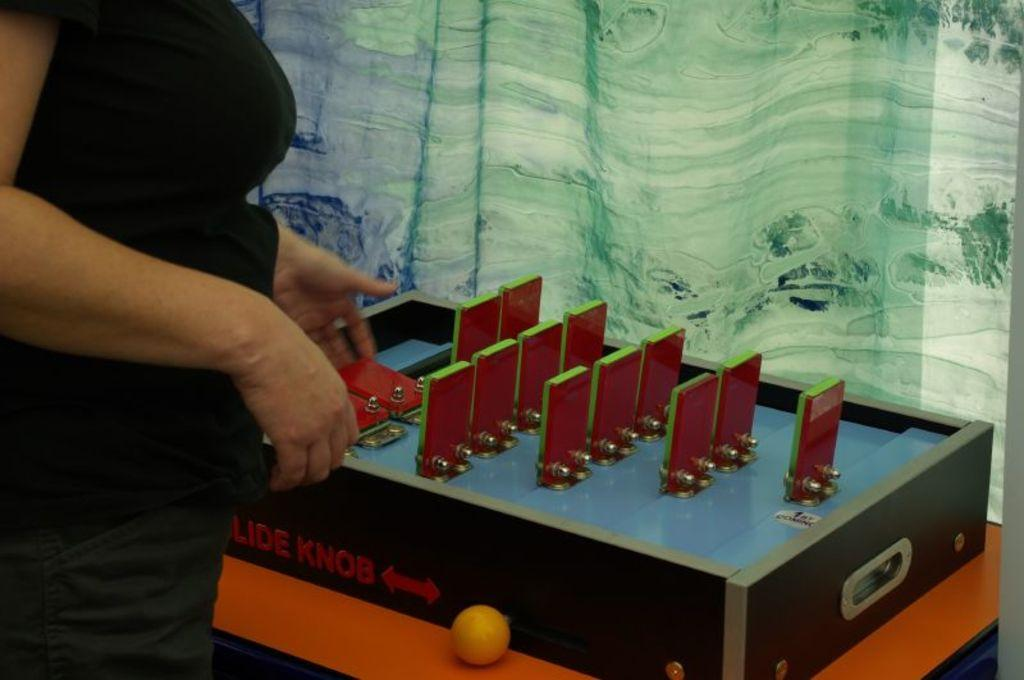Who is the main subject in the image? There is a woman standing in the image. What is the woman standing in front of? The woman is standing in front of a table. What can be seen in the background of the image? There is a curtain in the background of the image. What object is on the table in the image? There is a ball on the table in the image. What type of bulb is being used for teaching in the image? There is no bulb or teaching activity present in the image. What color is the cap on the woman's head in the image? The woman is not wearing a cap in the image. 